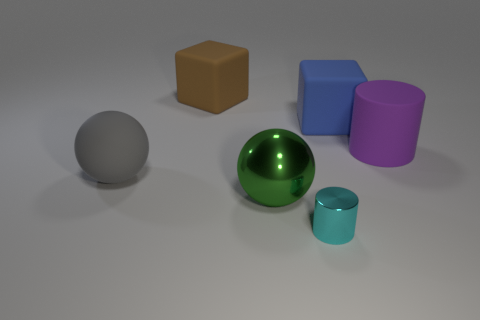Subtract all blue cylinders. Subtract all red blocks. How many cylinders are left? 2 Add 3 purple metal things. How many objects exist? 9 Subtract all cubes. How many objects are left? 4 Add 2 small green metal objects. How many small green metal objects exist? 2 Subtract 0 yellow cubes. How many objects are left? 6 Subtract all blue blocks. Subtract all big purple things. How many objects are left? 4 Add 3 small cyan things. How many small cyan things are left? 4 